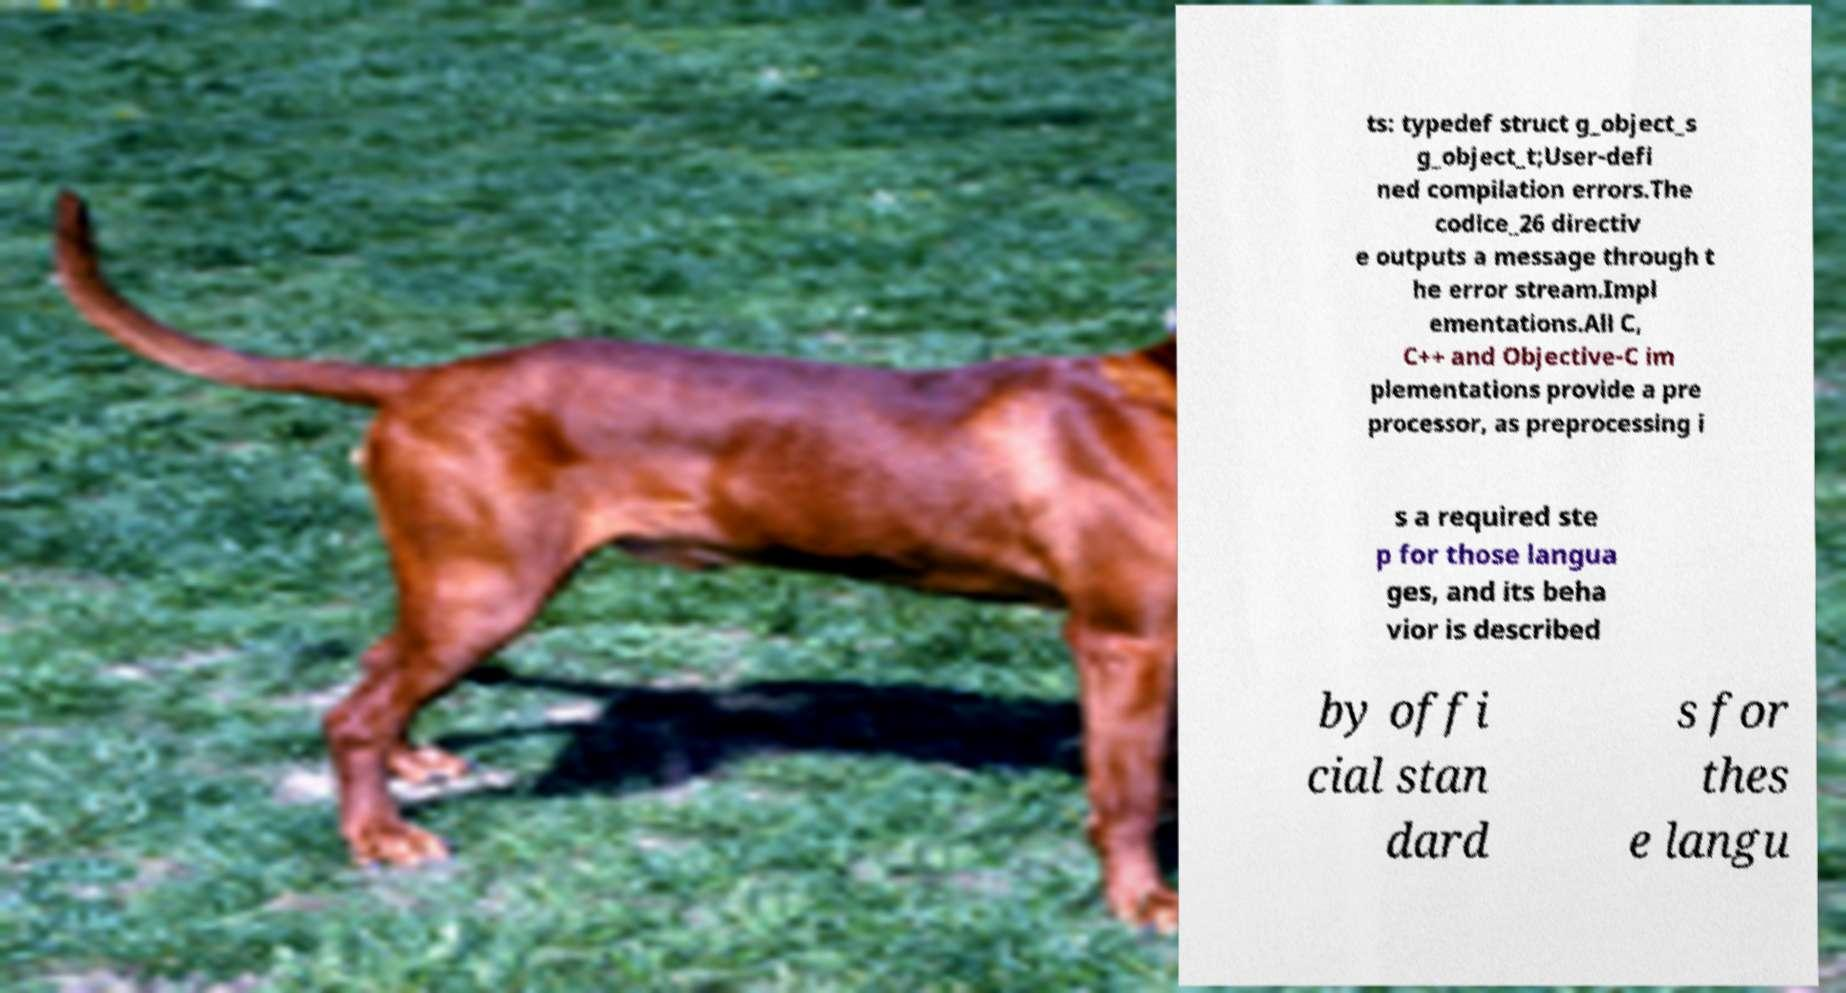For documentation purposes, I need the text within this image transcribed. Could you provide that? ts: typedef struct g_object_s g_object_t;User-defi ned compilation errors.The codice_26 directiv e outputs a message through t he error stream.Impl ementations.All C, C++ and Objective-C im plementations provide a pre processor, as preprocessing i s a required ste p for those langua ges, and its beha vior is described by offi cial stan dard s for thes e langu 